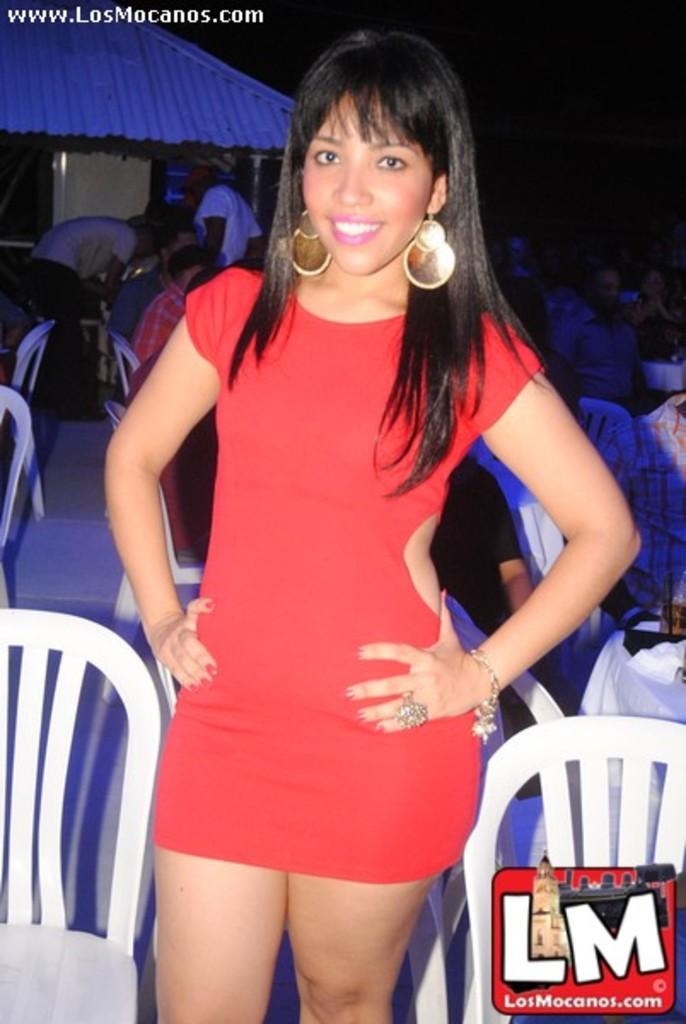<image>
Summarize the visual content of the image. Woman posing for a photo in front of some chairs and the letters LM under her. 